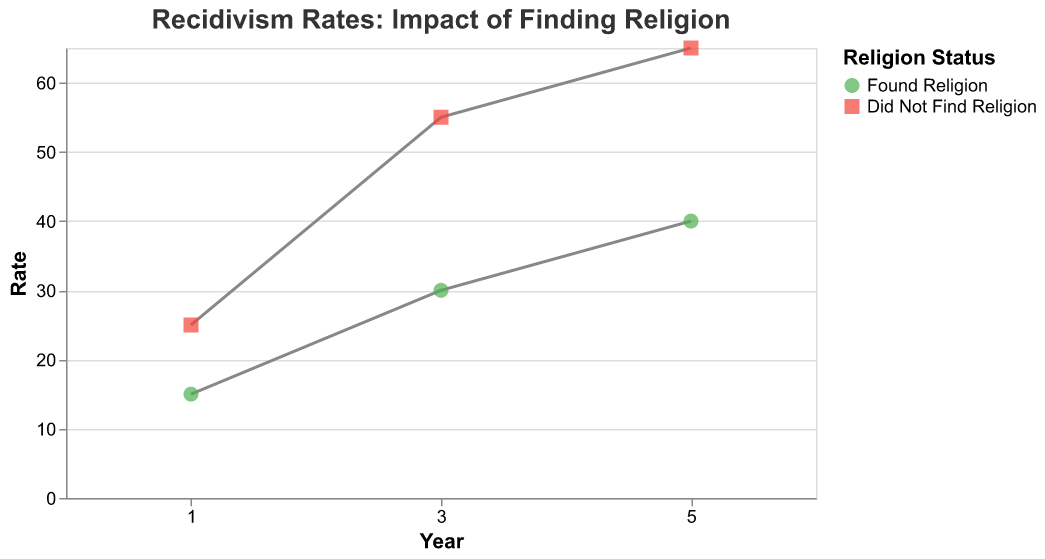What is the title of the figure? The title of the figure is the main heading and is often positioned at the top of the chart.
Answer: "Recidivism Rates: Impact of Finding Religion" How many years of recidivism rates are compared in the figure? By looking at the x-axis, we can see it lists the years over which recidivism rates are recorded.
Answer: 3 years What are the colors used to represent the different religion statuses? The legend shows the mapping of colors to religion statuses. "Found Religion" is mapped to green, and "Did Not Find Religion" is mapped to red.
Answer: Green and red Which group has a higher recidivism rate after one year? Look at the y-values for both groups at the 1-year mark. The red square marker is higher than the green circle marker.
Answer: Did Not Find Religion What is the difference in the 3-year recidivism rate between the two religion statuses? Identify the y-values for the 3-year rates for both groups and subtract the smaller value from the larger one. The 3-year rates are 30 for "Found Religion" and 55 for "Did Not Find Religion".
Answer: 25% Over which period do the recidivism rates increase the most for both groups? Calculate the difference in recidivism rates for each time period (1 to 3 years and 3 to 5 years) and compare them.
Answer: 1 to 3 years Which group shows a lower overall increase in recidivism rates from 1 year to 5 years? Determine the recidivism rate increase for each group from 1 year to 5 years and compare the values. "Found Religion" increases from 15 to 40, and "Did Not Find Religion" increases from 25 to 65.
Answer: Found Religion What trend do we observe for both groups in terms of recidivism rates over time? Look at the slope of the lines connecting the markers over the 1, 3, and 5-year marks. Both lines show an upward trend.
Answer: Increasing trend Which group has the highest recidivism rate at 5 years? Identify the y-values for both groups at the 5-year mark. The red square marker is higher than the green circle marker.
Answer: Did Not Find Religion 